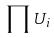Convert formula to latex. <formula><loc_0><loc_0><loc_500><loc_500>\prod U _ { i }</formula> 